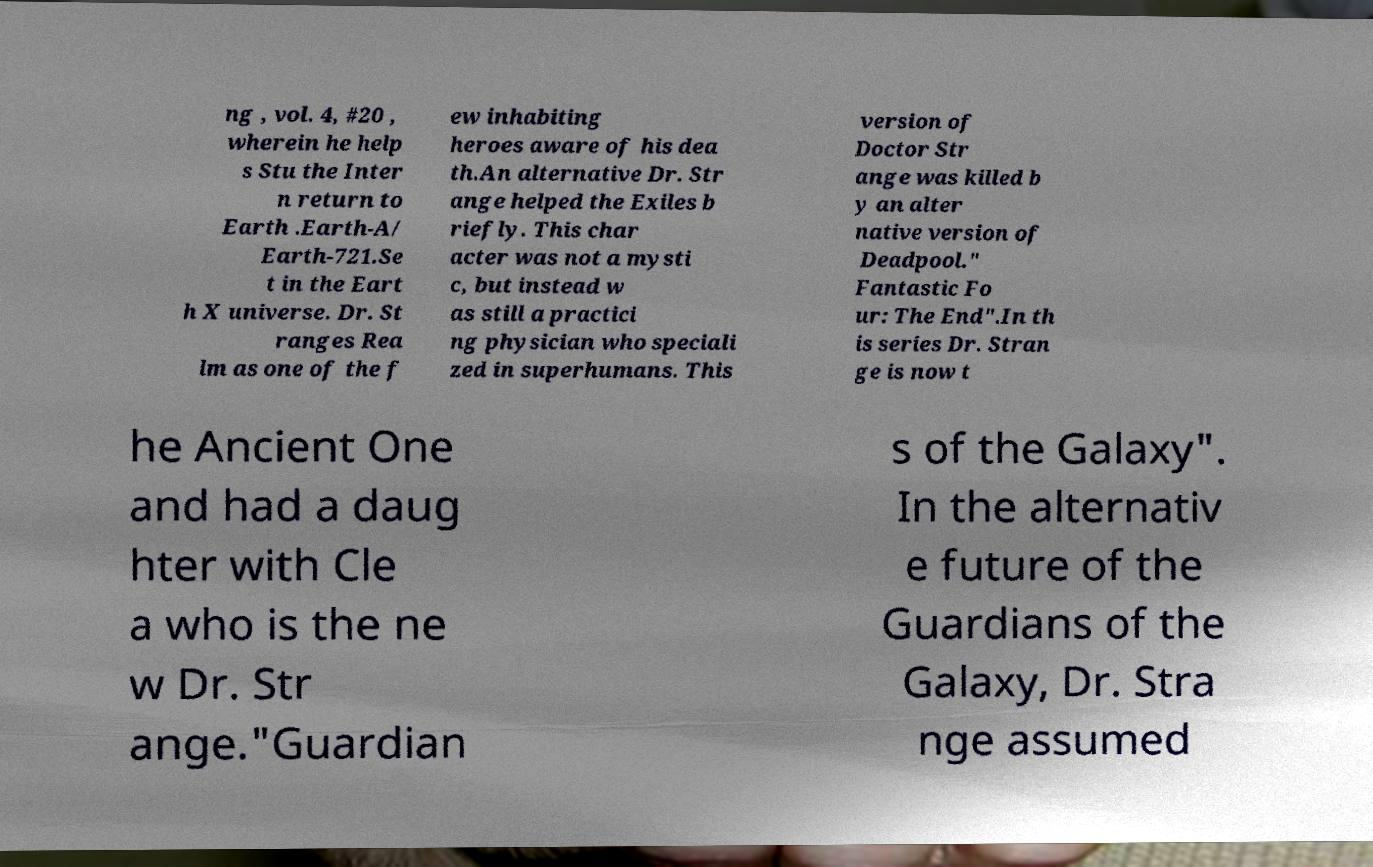What messages or text are displayed in this image? I need them in a readable, typed format. ng , vol. 4, #20 , wherein he help s Stu the Inter n return to Earth .Earth-A/ Earth-721.Se t in the Eart h X universe. Dr. St ranges Rea lm as one of the f ew inhabiting heroes aware of his dea th.An alternative Dr. Str ange helped the Exiles b riefly. This char acter was not a mysti c, but instead w as still a practici ng physician who speciali zed in superhumans. This version of Doctor Str ange was killed b y an alter native version of Deadpool." Fantastic Fo ur: The End".In th is series Dr. Stran ge is now t he Ancient One and had a daug hter with Cle a who is the ne w Dr. Str ange."Guardian s of the Galaxy". In the alternativ e future of the Guardians of the Galaxy, Dr. Stra nge assumed 